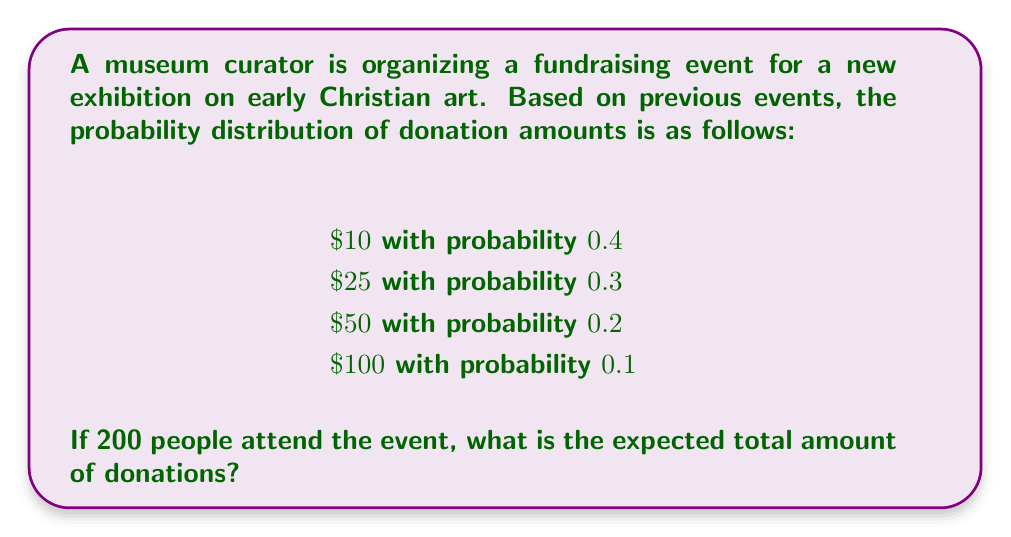Help me with this question. To solve this problem, we need to follow these steps:

1. Calculate the expected value of a single donation.
2. Multiply the expected value by the number of attendees.

Step 1: Calculate the expected value of a single donation

The expected value of a discrete random variable is given by the formula:

$$ E(X) = \sum_{i=1}^{n} x_i \cdot p(x_i) $$

Where $x_i$ are the possible values and $p(x_i)$ are their respective probabilities.

Let's calculate this for our donation amounts:

$$ E(X) = 10 \cdot 0.4 + 25 \cdot 0.3 + 50 \cdot 0.2 + 100 \cdot 0.1 $$
$$ E(X) = 4 + 7.5 + 10 + 10 $$
$$ E(X) = 31.5 $$

So, the expected value of a single donation is $31.50.

Step 2: Multiply the expected value by the number of attendees

Since there are 200 attendees, and each is expected to donate an average of $31.50, we multiply these numbers:

$$ \text{Total Expected Donations} = 200 \cdot 31.5 = 6300 $$

Therefore, the expected total amount of donations is $6,300.
Answer: $6,300 